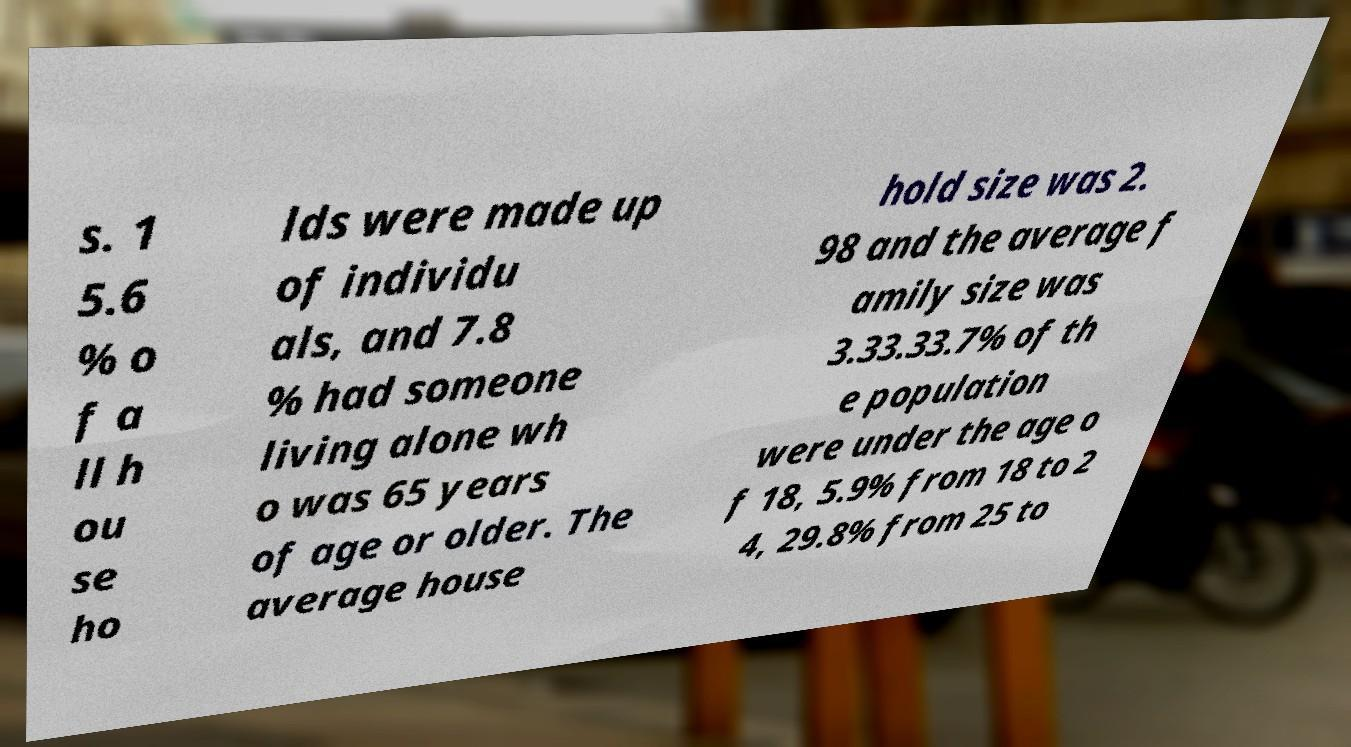I need the written content from this picture converted into text. Can you do that? s. 1 5.6 % o f a ll h ou se ho lds were made up of individu als, and 7.8 % had someone living alone wh o was 65 years of age or older. The average house hold size was 2. 98 and the average f amily size was 3.33.33.7% of th e population were under the age o f 18, 5.9% from 18 to 2 4, 29.8% from 25 to 